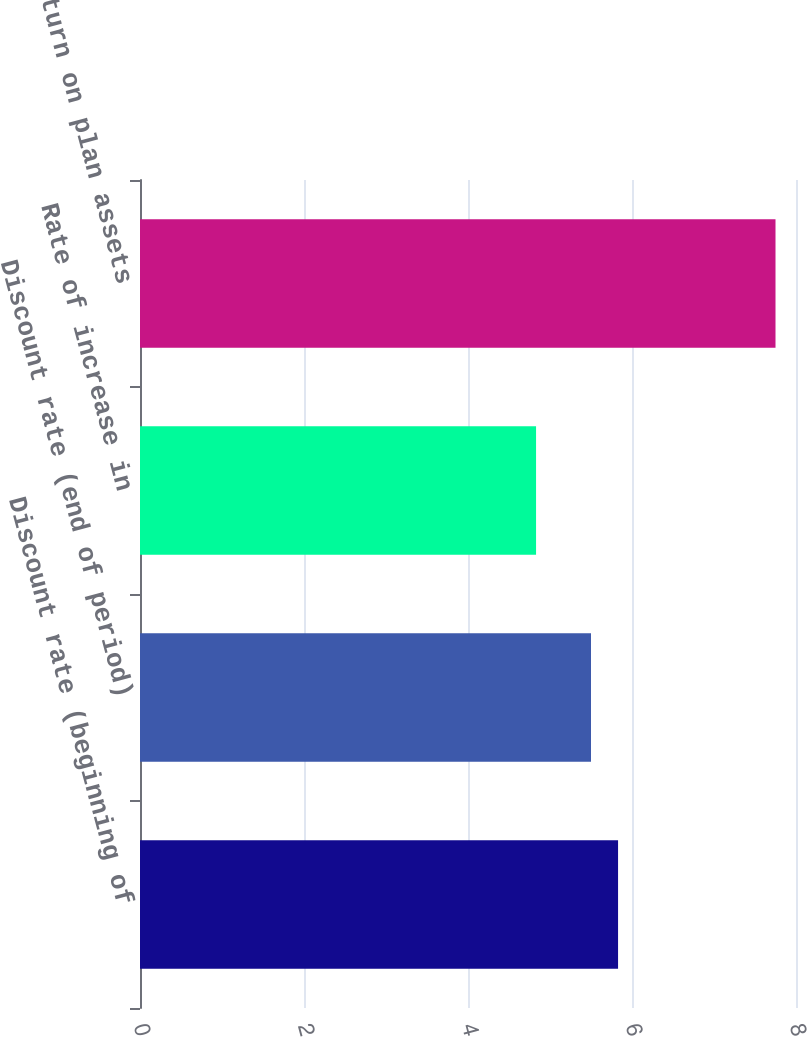<chart> <loc_0><loc_0><loc_500><loc_500><bar_chart><fcel>Discount rate (beginning of<fcel>Discount rate (end of period)<fcel>Rate of increase in<fcel>Expected return on plan assets<nl><fcel>5.83<fcel>5.5<fcel>4.83<fcel>7.75<nl></chart> 